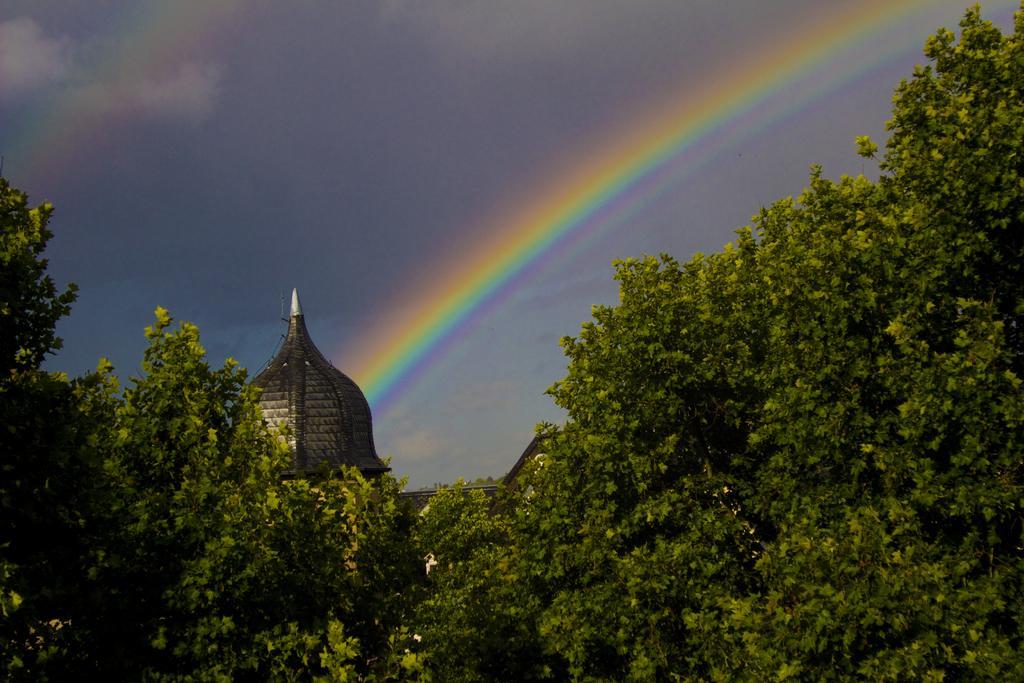Please provide a concise description of this image. In this image in front there are trees. In the center of the image there is a building. In the background of the image there is a rainbow and there is sky. 